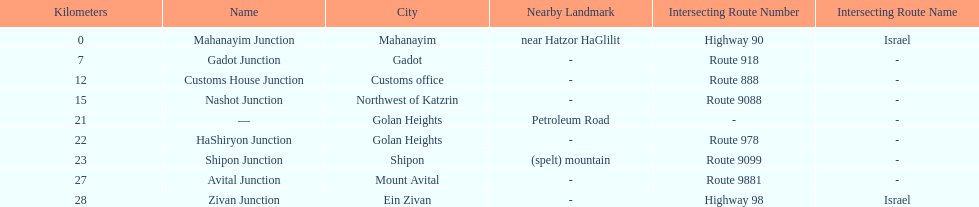What junction is the furthest from mahanayim junction? Zivan Junction. 